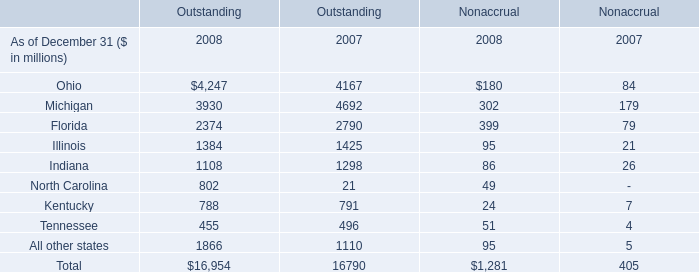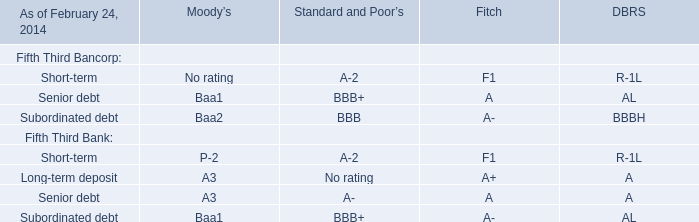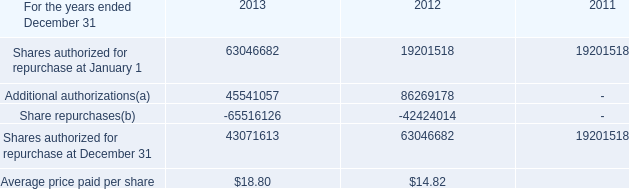what's the total amount of Ohio of Outstanding 2008, and Share repurchases of 2013 ? 
Computations: (4247.0 + 65516126.0)
Answer: 65520373.0. 